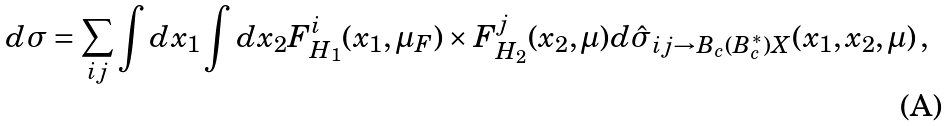Convert formula to latex. <formula><loc_0><loc_0><loc_500><loc_500>d \sigma = \sum _ { i j } \int d x _ { 1 } \int d x _ { 2 } F ^ { i } _ { H _ { 1 } } ( x _ { 1 } , \mu _ { F } ) \times F ^ { j } _ { H _ { 2 } } ( x _ { 2 } , \mu ) d \hat { \sigma } _ { i j \rightarrow B _ { c } ( B _ { c } ^ { * } ) X } ( x _ { 1 } , x _ { 2 } , \mu ) \, ,</formula> 